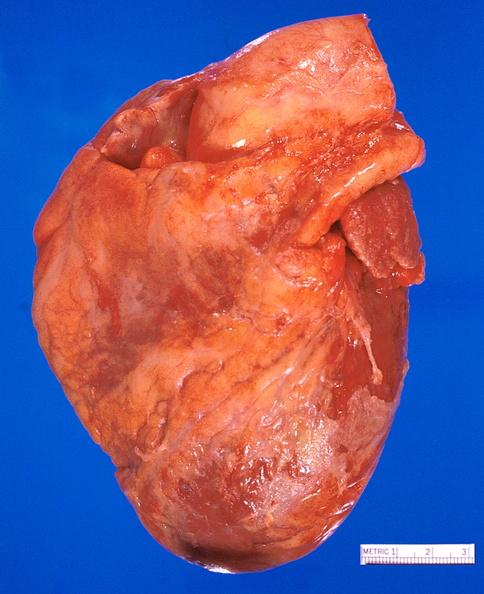does this image show heart, myocardial infarction free wall, 6 days old, in a patient with diabetes mellitus and hypertension?
Answer the question using a single word or phrase. Yes 